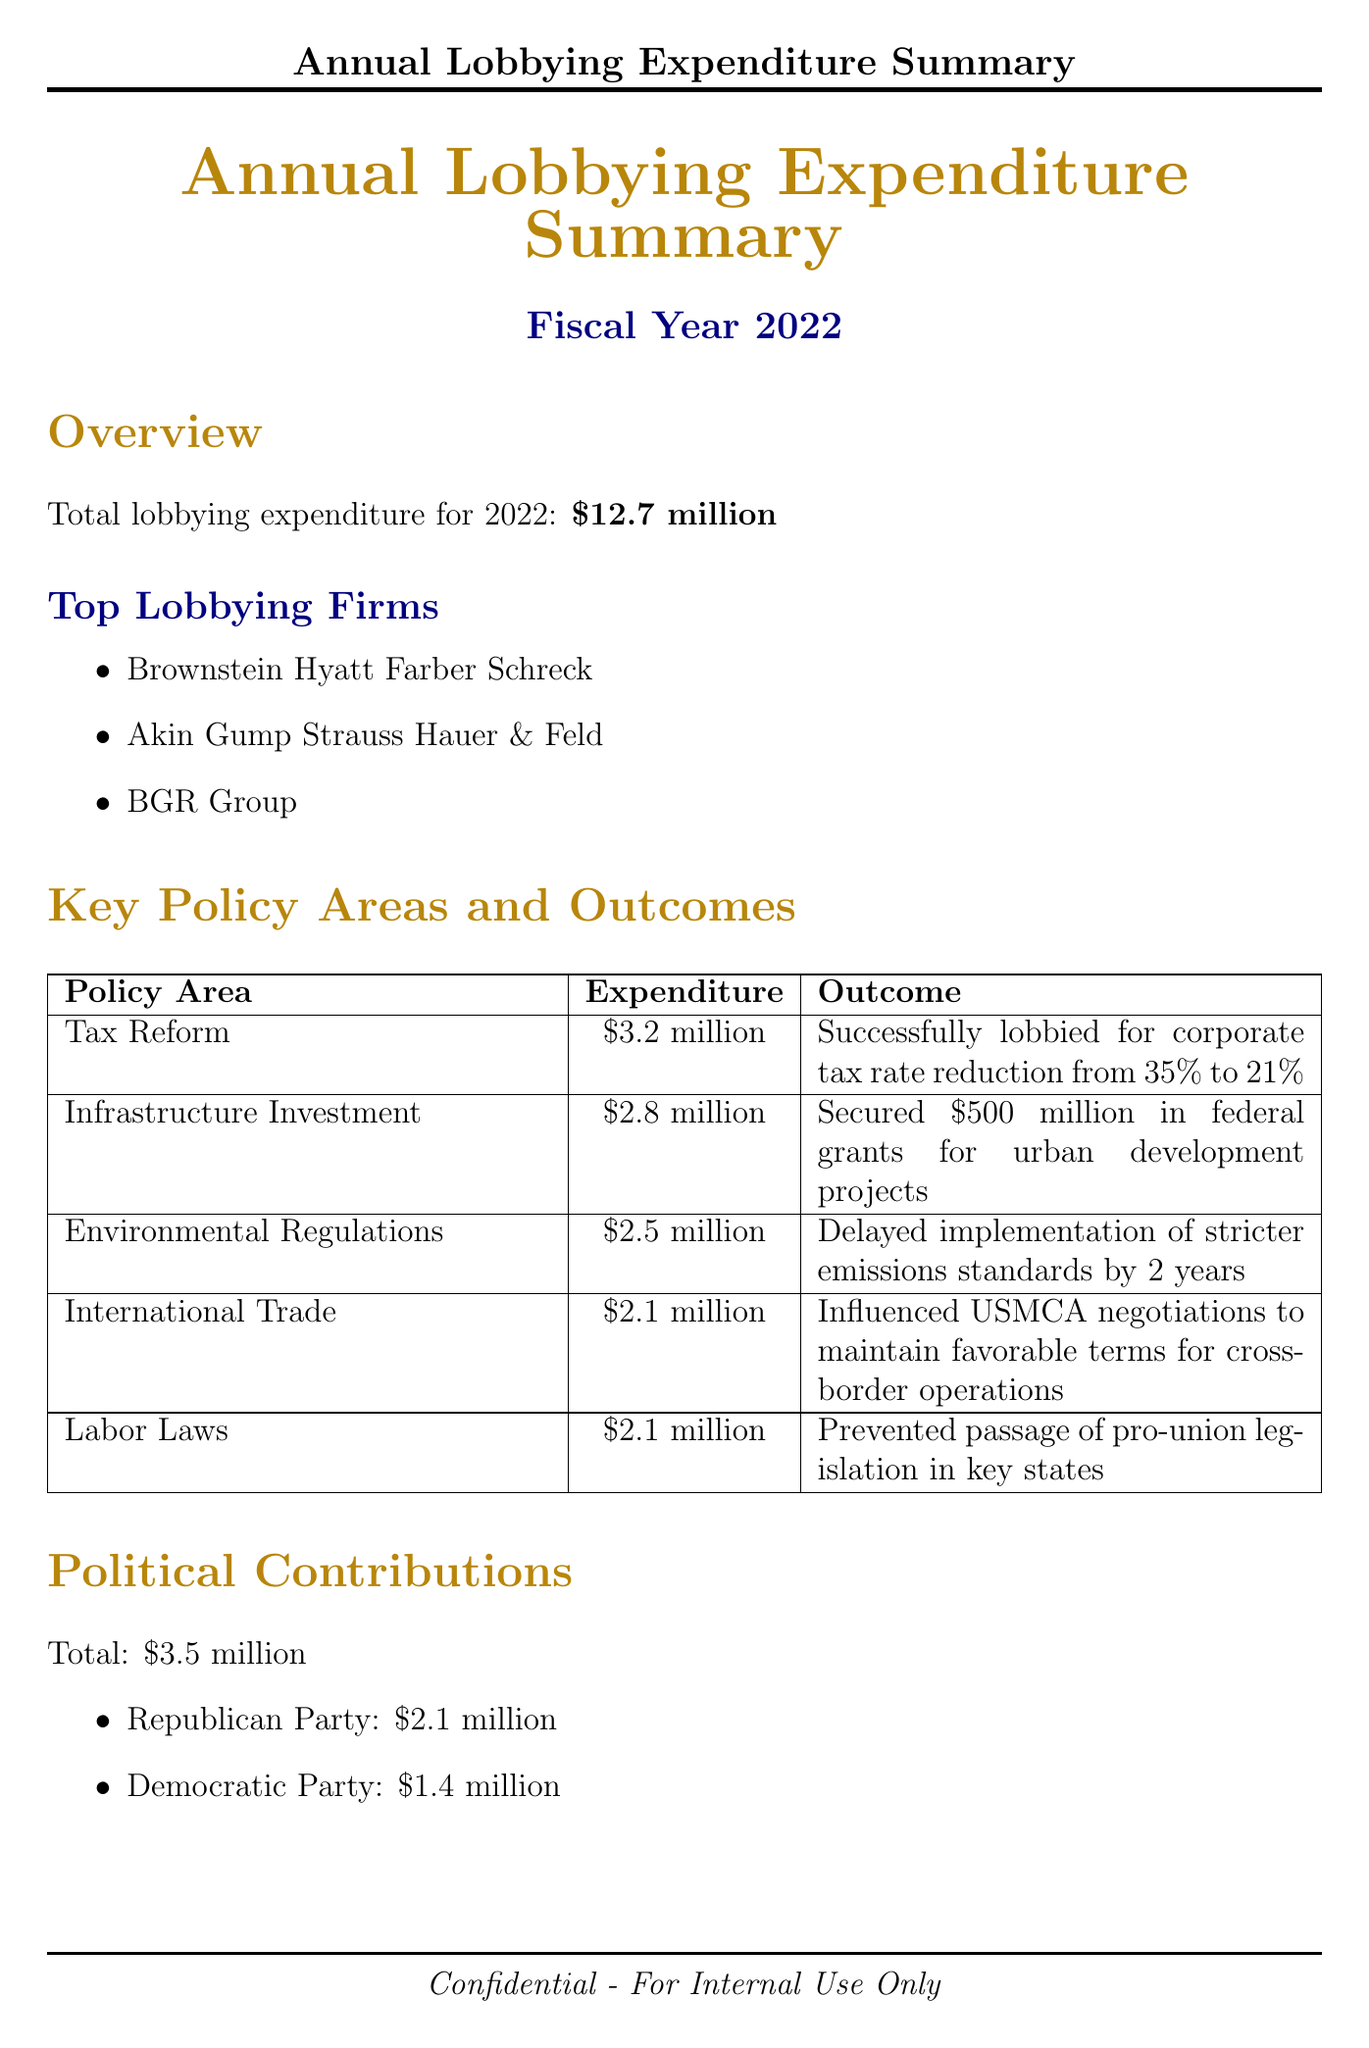What is the total lobbying expenditure for 2022? The total lobbying expenditure for 2022 is stated in the document as \$12.7 million.
Answer: \$12.7 million Which lobbying firm had the highest expenditure? The document lists the top lobbying firms but does not quantify their expenditures individually; hence this question is based on the available firms.
Answer: Not specified What is the expenditure for Tax Reform? The expenditure for Tax Reform is specifically listed in the document as \$3.2 million.
Answer: \$3.2 million Who is the Senate Minority Whip mentioned in the report? The document identifies the key relationships and their titles, stating that Senator John Thune holds the position of Senate Minority Whip.
Answer: Senator John Thune What was the outcome of the lobbying for Infrastructure Investment? The document states that the outcome for Infrastructure Investment was securing \$500 million in federal grants for urban development projects.
Answer: Secured \$500 million in federal grants How much was contributed to the Republican Party? The total contribution to the Republican Party is provided in the political contributions section as \$2.1 million.
Answer: \$2.1 million Which two industry associations are mentioned in the document? The document lists the industry associations along with their roles and contributions; the two mentioned are Business Roundtable and U.S. Chamber of Commerce.
Answer: Business Roundtable, U.S. Chamber of Commerce What are the future lobbying priorities? The document outlines future lobbying priorities, listing them as 5G infrastructure development, AI regulations, healthcare cost containment, and cybersecurity standards.
Answer: 5G infrastructure development, Artificial Intelligence regulations, Healthcare cost containment, Cybersecurity standards for businesses 